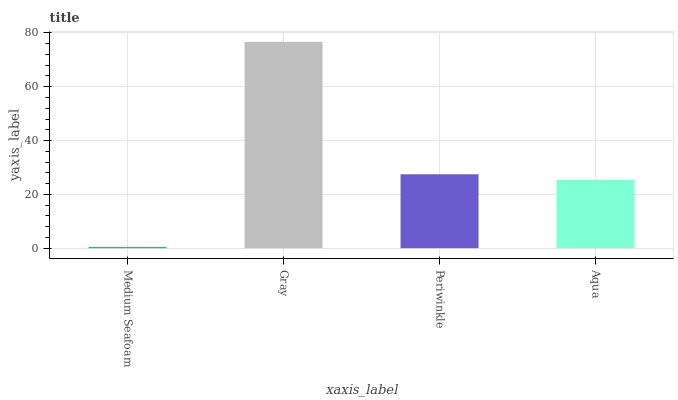Is Medium Seafoam the minimum?
Answer yes or no. Yes. Is Gray the maximum?
Answer yes or no. Yes. Is Periwinkle the minimum?
Answer yes or no. No. Is Periwinkle the maximum?
Answer yes or no. No. Is Gray greater than Periwinkle?
Answer yes or no. Yes. Is Periwinkle less than Gray?
Answer yes or no. Yes. Is Periwinkle greater than Gray?
Answer yes or no. No. Is Gray less than Periwinkle?
Answer yes or no. No. Is Periwinkle the high median?
Answer yes or no. Yes. Is Aqua the low median?
Answer yes or no. Yes. Is Gray the high median?
Answer yes or no. No. Is Periwinkle the low median?
Answer yes or no. No. 